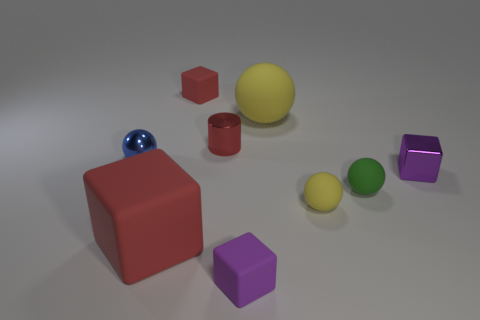Does the small red block have the same material as the red thing that is to the right of the tiny red rubber object?
Provide a short and direct response. No. What number of other objects are there of the same shape as the blue thing?
Your response must be concise. 3. There is a cube to the right of the sphere to the right of the yellow matte ball that is in front of the tiny cylinder; what is it made of?
Your answer should be very brief. Metal. Is the number of large red objects behind the red metal thing the same as the number of red metal things?
Offer a terse response. No. Does the tiny purple thing on the left side of the small shiny block have the same material as the tiny cube that is on the right side of the green ball?
Keep it short and to the point. No. There is a yellow matte object that is in front of the metallic ball; is its shape the same as the red thing that is in front of the small red cylinder?
Keep it short and to the point. No. Are there fewer tiny purple blocks on the left side of the small red matte block than green balls?
Your answer should be very brief. Yes. How many shiny cylinders have the same color as the large rubber block?
Make the answer very short. 1. There is a rubber sphere behind the small blue metal ball; how big is it?
Ensure brevity in your answer.  Large. The metallic thing in front of the ball on the left side of the large rubber object that is to the right of the red shiny thing is what shape?
Ensure brevity in your answer.  Cube. 